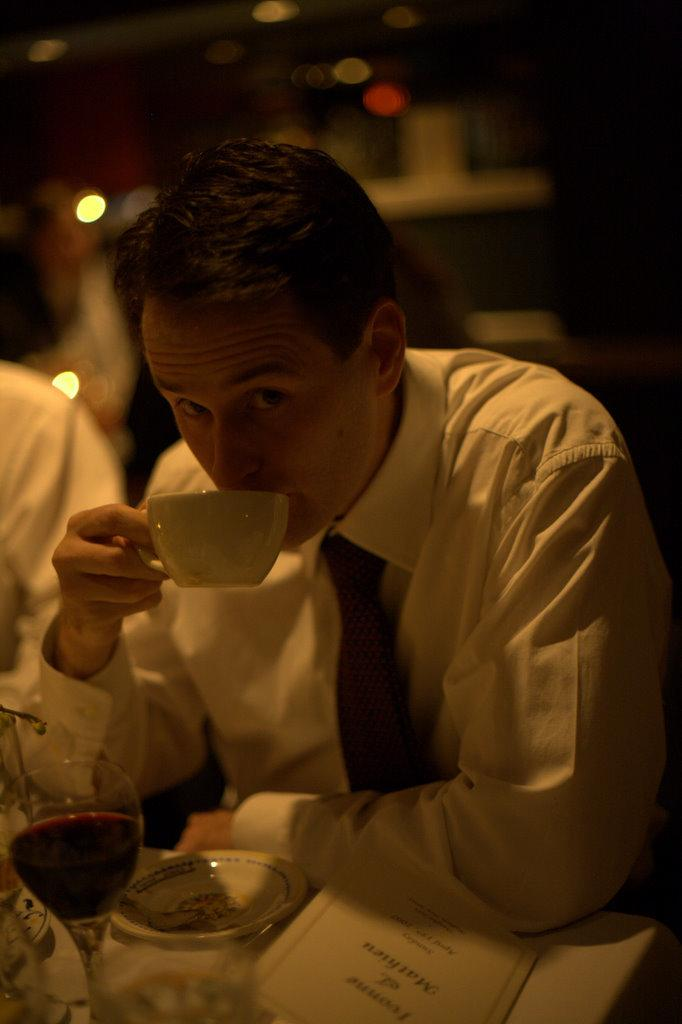What is the man in the image doing? The man is sitting in the image. What is the man holding in the image? The man is holding a cup in the image. What other objects can be seen in the image? There is a plate, a paper, and a wine glass in the image. What type of music is being played in the image? There is no indication of music being played in the image. What shape is the bomb in the image? There is no bomb present in the image. 